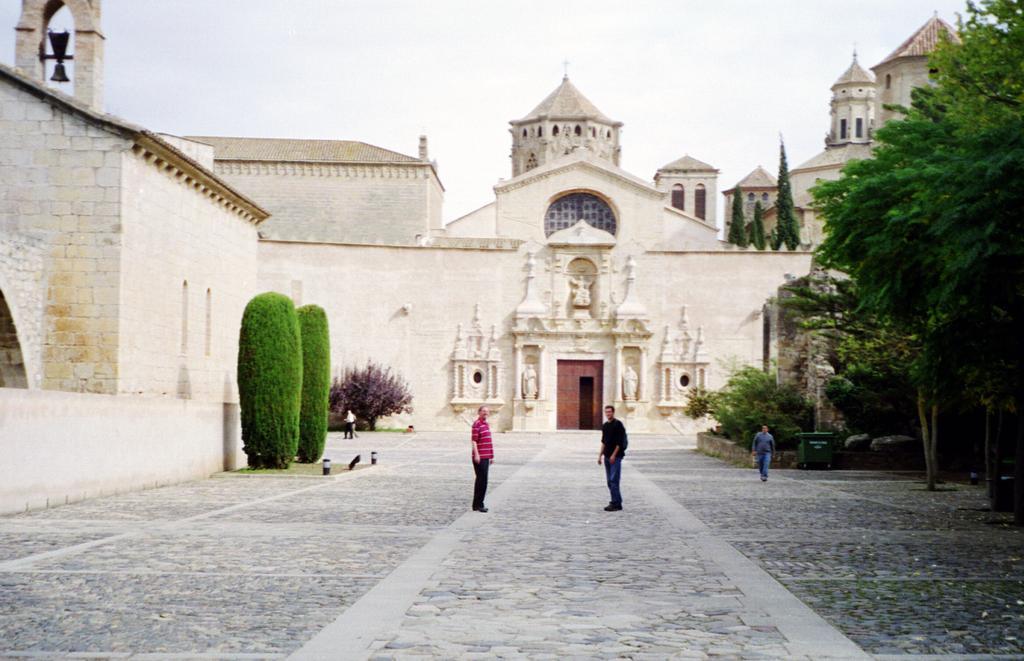Could you give a brief overview of what you see in this image? At the bottom of the picture, we see the pavement and in the middle of the picture, we see two men are standing. The man on the right side is walking. On the right side, we see the trees. On the left side, we see a building in white color and beside that, there are hedging plants. Beside that, the man is standing. In the background, we see the buildings. At the top, we see the sky. 